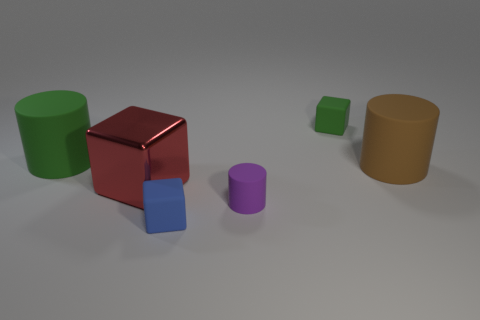Subtract all tiny purple matte cylinders. How many cylinders are left? 2 Add 1 rubber blocks. How many objects exist? 7 Add 1 large blue metal spheres. How many large blue metal spheres exist? 1 Subtract 1 green blocks. How many objects are left? 5 Subtract all yellow cylinders. Subtract all red spheres. How many cylinders are left? 3 Subtract all big red metallic objects. Subtract all purple cylinders. How many objects are left? 4 Add 3 small green rubber objects. How many small green rubber objects are left? 4 